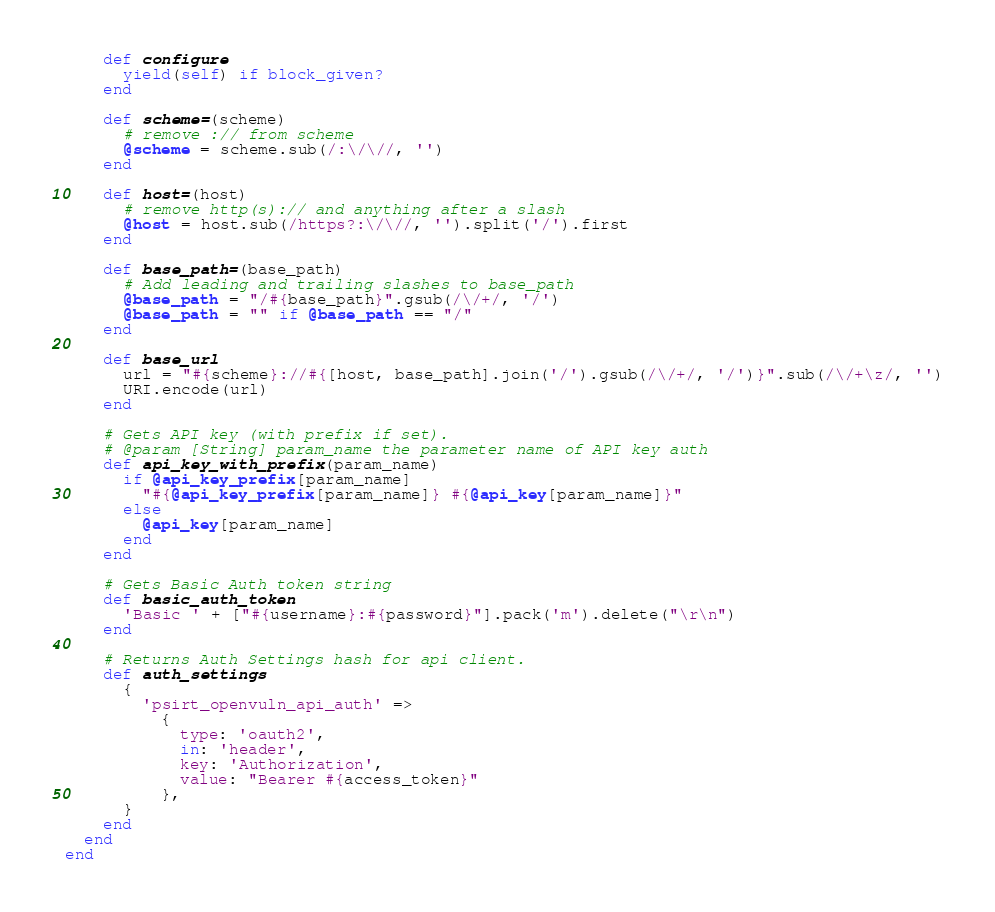<code> <loc_0><loc_0><loc_500><loc_500><_Ruby_>
    def configure
      yield(self) if block_given?
    end

    def scheme=(scheme)
      # remove :// from scheme
      @scheme = scheme.sub(/:\/\//, '')
    end

    def host=(host)
      # remove http(s):// and anything after a slash
      @host = host.sub(/https?:\/\//, '').split('/').first
    end

    def base_path=(base_path)
      # Add leading and trailing slashes to base_path
      @base_path = "/#{base_path}".gsub(/\/+/, '/')
      @base_path = "" if @base_path == "/"
    end

    def base_url
      url = "#{scheme}://#{[host, base_path].join('/').gsub(/\/+/, '/')}".sub(/\/+\z/, '')
      URI.encode(url)
    end

    # Gets API key (with prefix if set).
    # @param [String] param_name the parameter name of API key auth
    def api_key_with_prefix(param_name)
      if @api_key_prefix[param_name]
        "#{@api_key_prefix[param_name]} #{@api_key[param_name]}"
      else
        @api_key[param_name]
      end
    end

    # Gets Basic Auth token string
    def basic_auth_token
      'Basic ' + ["#{username}:#{password}"].pack('m').delete("\r\n")
    end

    # Returns Auth Settings hash for api client.
    def auth_settings
      {
        'psirt_openvuln_api_auth' =>
          {
            type: 'oauth2',
            in: 'header',
            key: 'Authorization',
            value: "Bearer #{access_token}"
          },
      }
    end
  end
end
</code> 